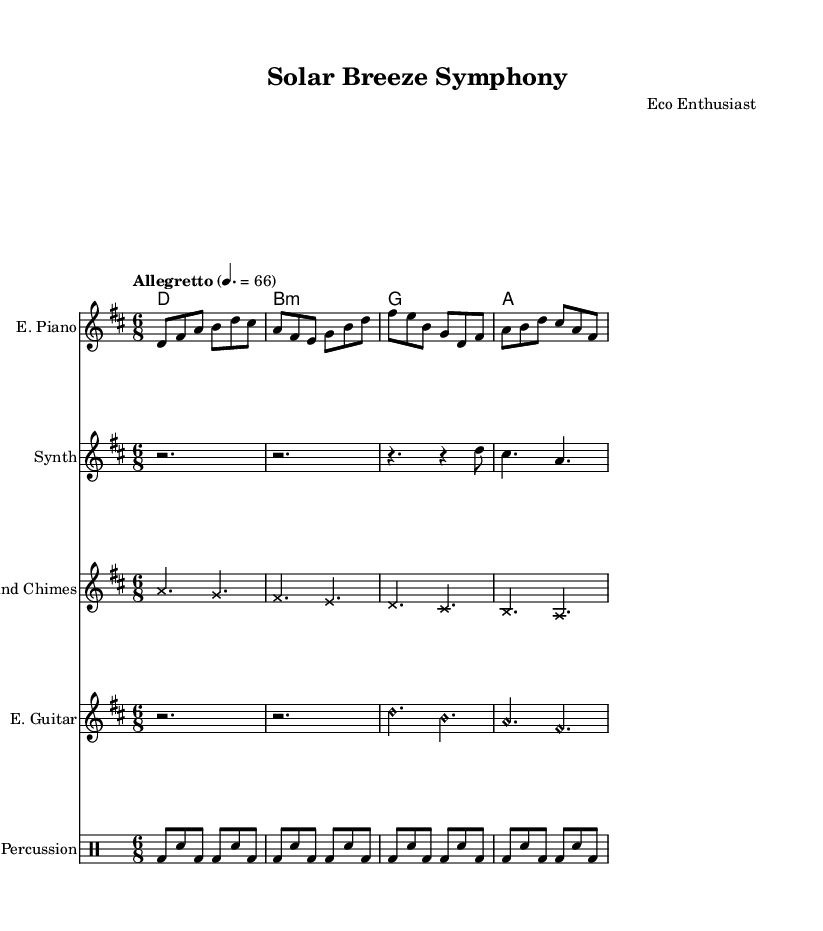What is the key signature of this music? The key signature is indicated at the beginning of the score and is D major, which has two sharps (F# and C#).
Answer: D major What is the time signature of this piece? The time signature is shown at the beginning of the score and is 6/8, meaning there are six beats in a measure, and each eighth note receives one beat.
Answer: 6/8 What is the tempo marking? The tempo marking tells the speed of the piece and is indicated as "Allegretto" with a metronome mark of 66 beats per minute.
Answer: Allegretto How many measures are in the electric piano part? By counting the number of measure bars in the electric piano notation, there are four measures listed for this instrument.
Answer: 4 Which instruments have harmonics indicated in their notation? The score shows that the electric guitar part has harmonics indicated by the notation style 'harmonic,' specifically in the first measure of that staff.
Answer: Electric Guitar What type of sound does the wind chimes part represent, based on their notation style? The wind chimes part uses a unique note head style labeled as 'cross,' which is often used to represent percussive or special sound effects associated with chimes.
Answer: Cross Which chord is played in the first measure of the chord names? The chord names indicate a D major chord is played in the first measure as represented by the first symbol in this section of the score.
Answer: D 